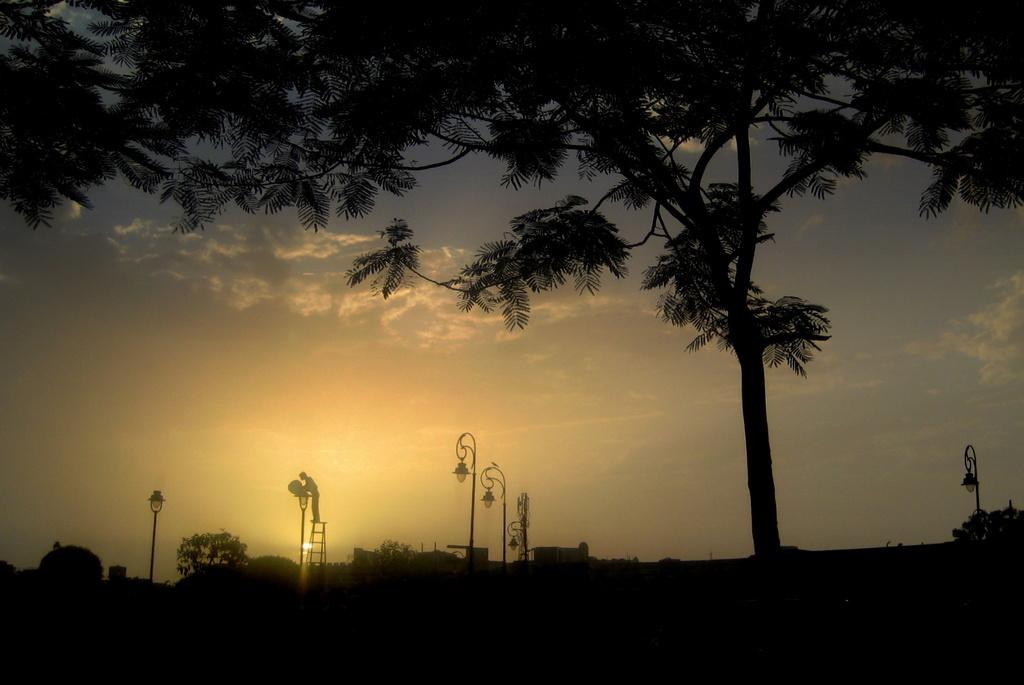What structures can be seen in the image? There are houses in the image. What other objects are present in the image besides houses? There are poles and trees in the image. Can you describe the tree in the foreground of the image? Yes, there is a tree in the foreground of the image. What is visible at the top of the image? The sky is visible at the top of the image. How would you describe the sky in the image? The sky appears to be clear in the image. What type of lace can be seen on the field in the image? There is no field or lace present in the image. What offer is being made by the trees in the image? There is no offer being made by the trees in the image; they are simply trees. 